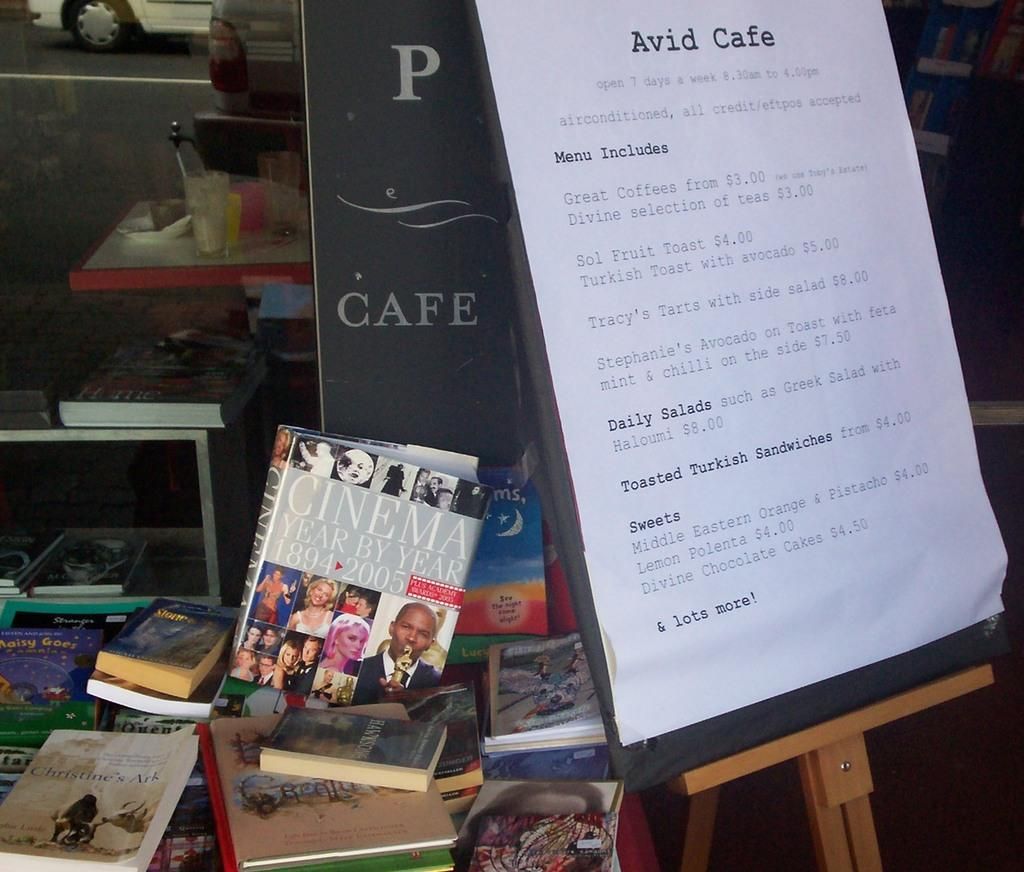Provide a one-sentence caption for the provided image. a table with books on it outside the Avid Cafe. 